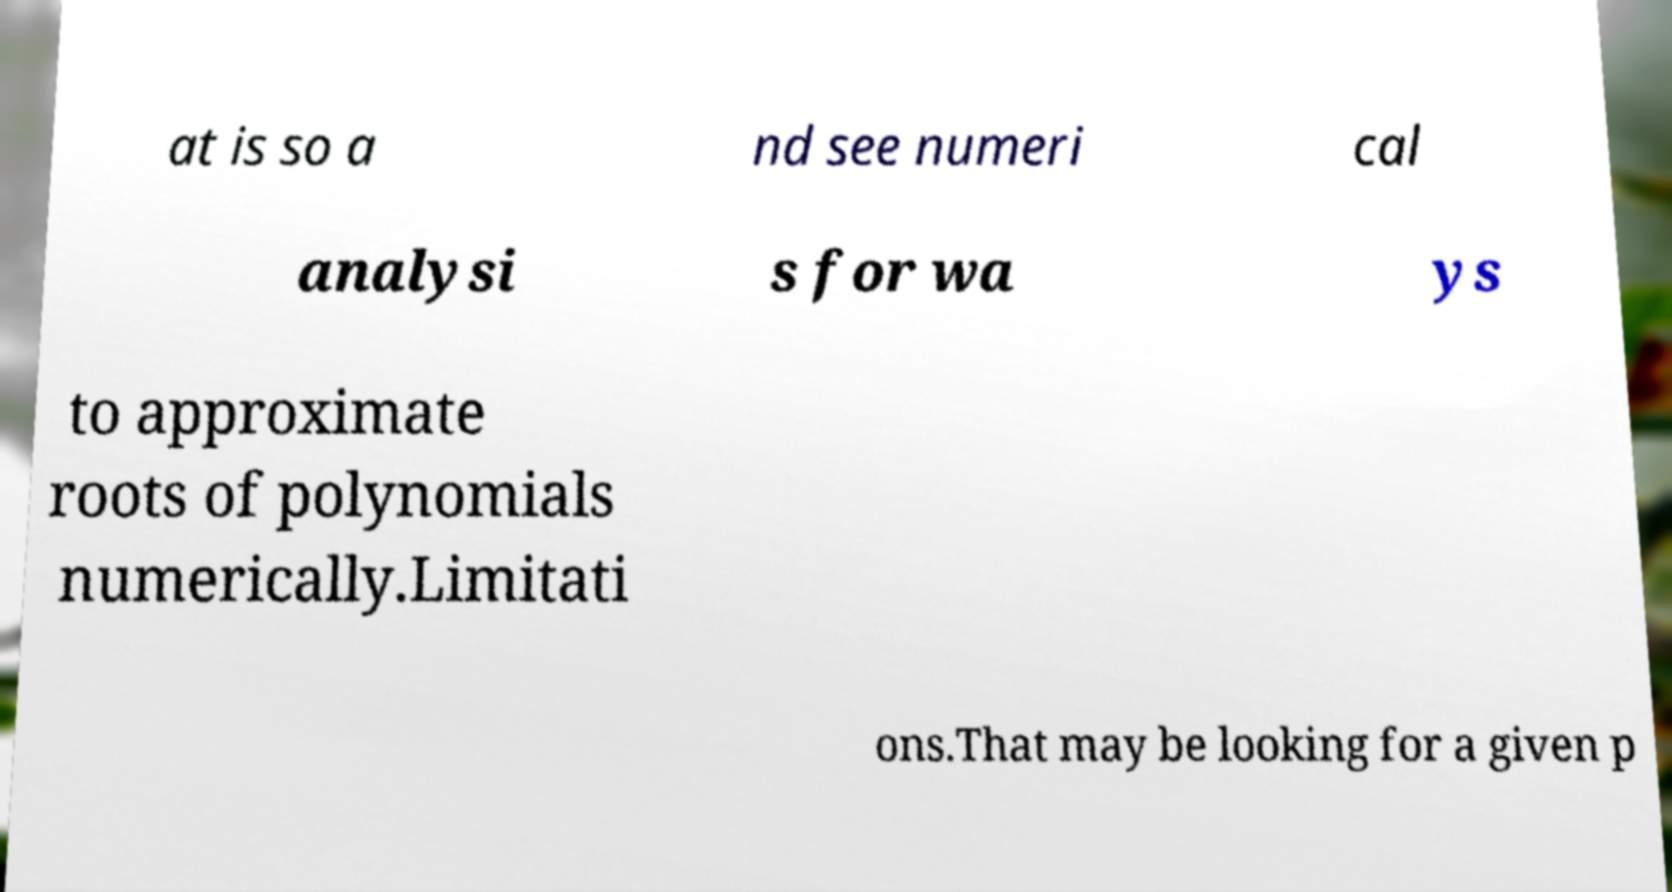Please identify and transcribe the text found in this image. at is so a nd see numeri cal analysi s for wa ys to approximate roots of polynomials numerically.Limitati ons.That may be looking for a given p 